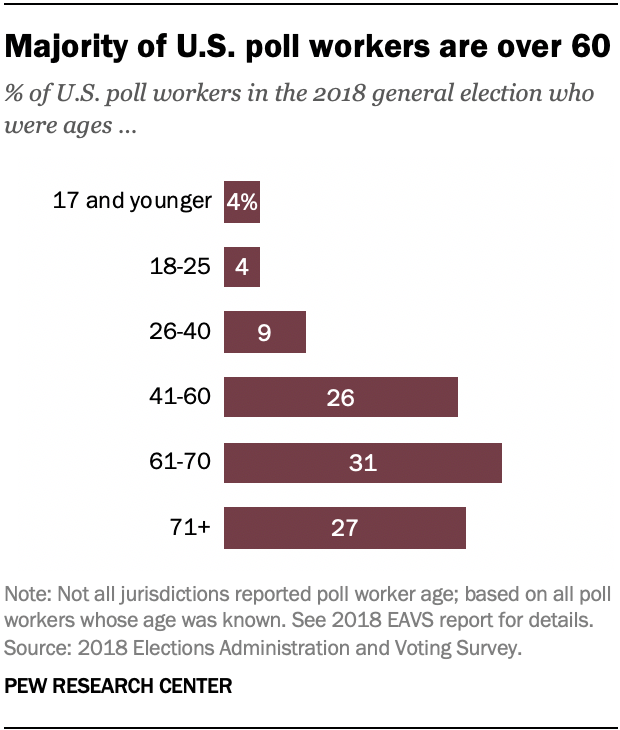Highlight a few significant elements in this photo. The value of the largest bar is 31. The second-largest bar has a product of 472.5. The median of all the bars is also known. 